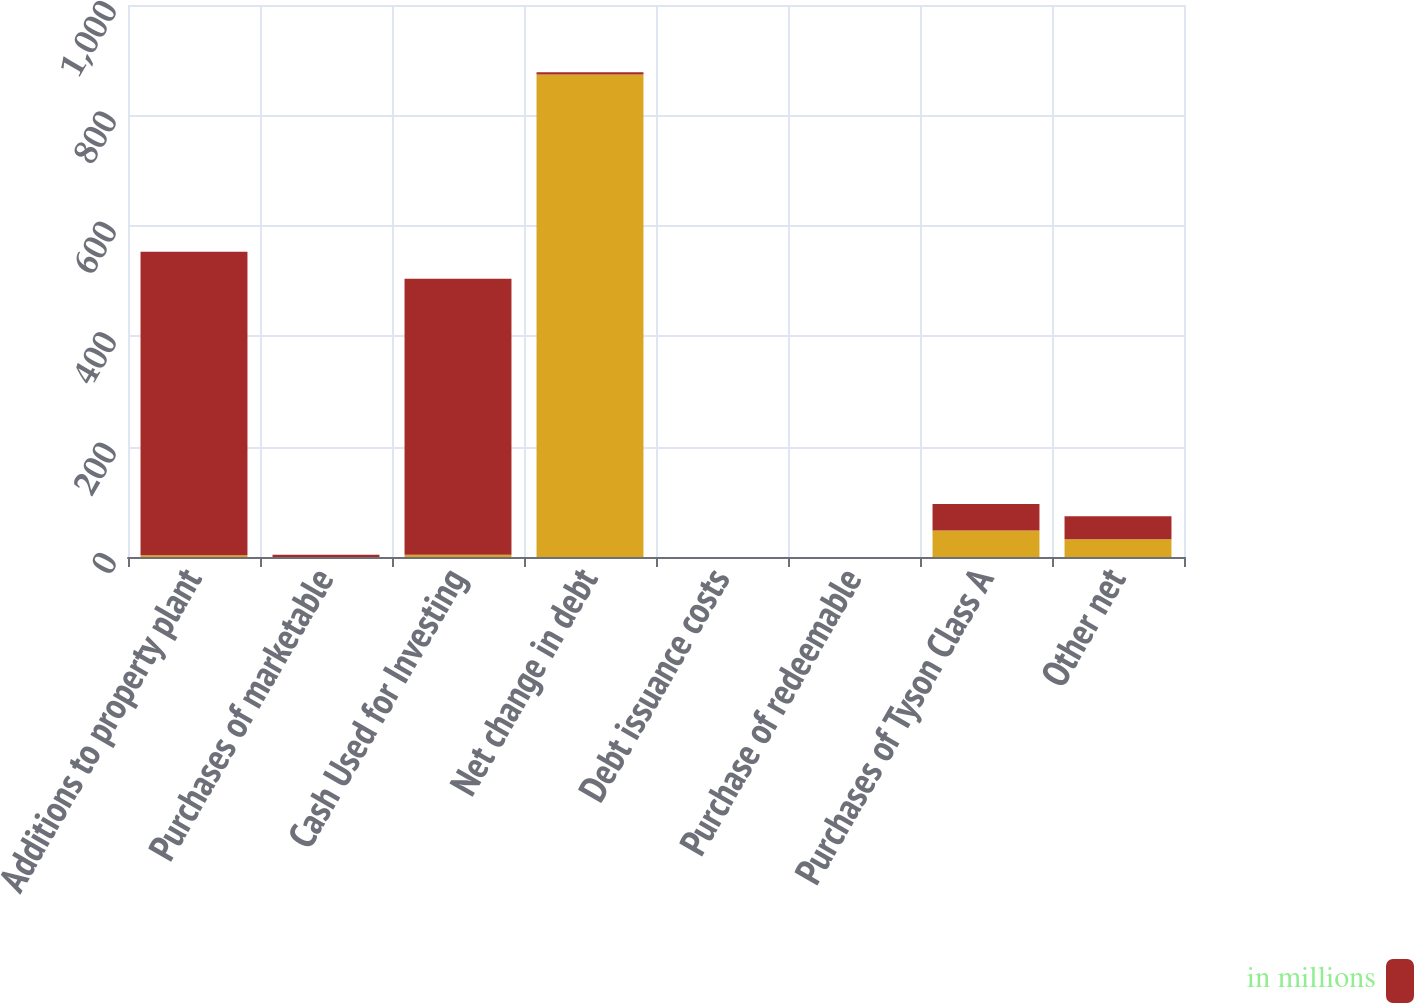Convert chart. <chart><loc_0><loc_0><loc_500><loc_500><stacked_bar_chart><ecel><fcel>Additions to property plant<fcel>Purchases of marketable<fcel>Cash Used for Investing<fcel>Net change in debt<fcel>Debt issuance costs<fcel>Purchase of redeemable<fcel>Purchases of Tyson Class A<fcel>Other net<nl><fcel>nan<fcel>3<fcel>0<fcel>4<fcel>874<fcel>0<fcel>0<fcel>48<fcel>32<nl><fcel>in millions<fcel>550<fcel>4<fcel>500<fcel>4<fcel>0<fcel>0<fcel>48<fcel>42<nl></chart> 